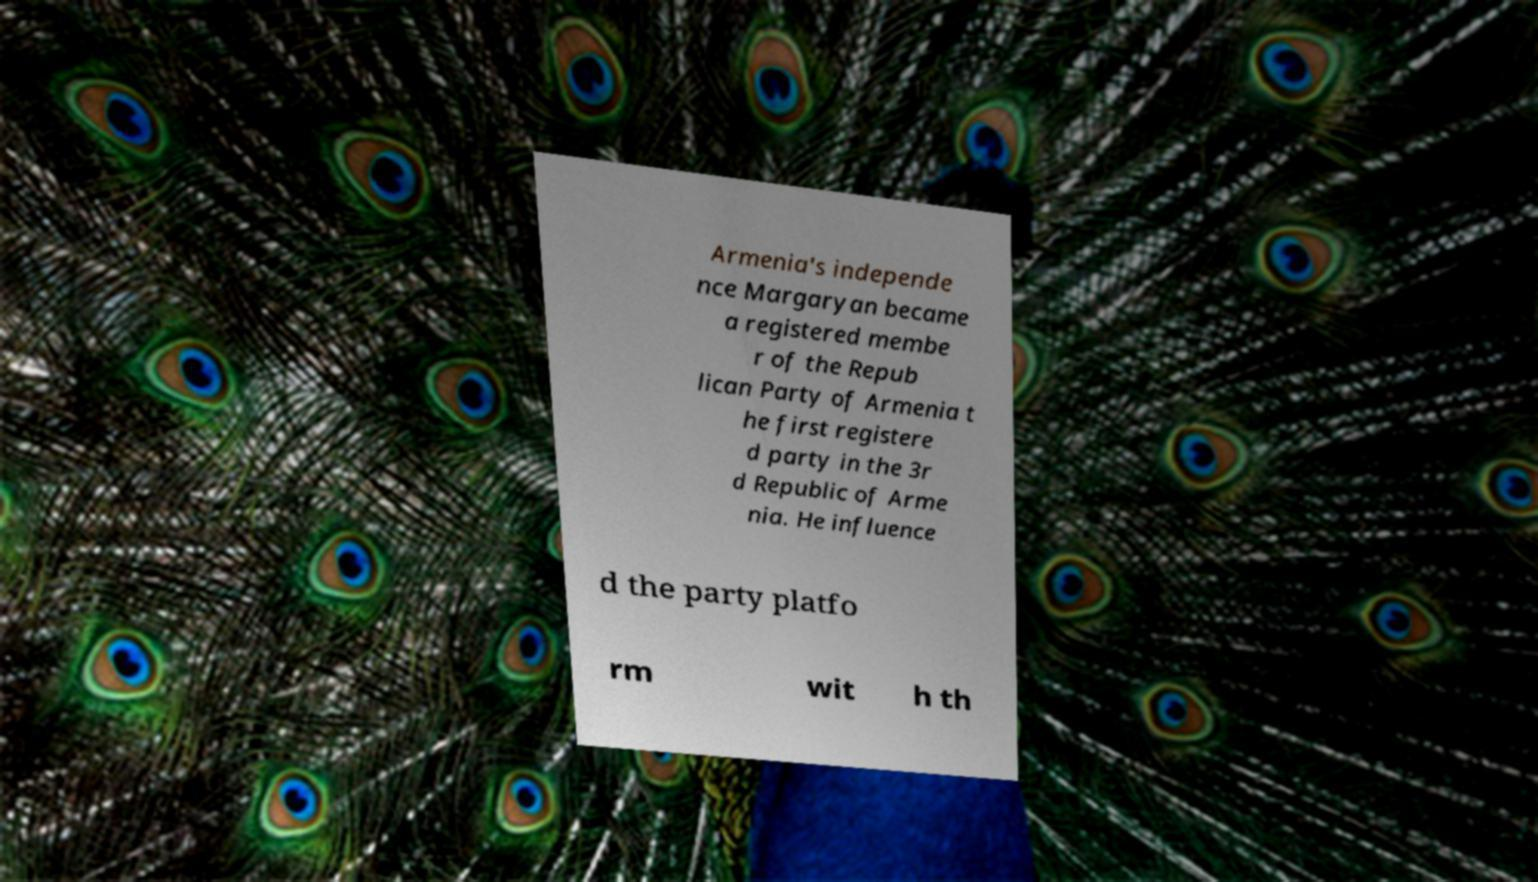Please read and relay the text visible in this image. What does it say? Armenia's independe nce Margaryan became a registered membe r of the Repub lican Party of Armenia t he first registere d party in the 3r d Republic of Arme nia. He influence d the party platfo rm wit h th 